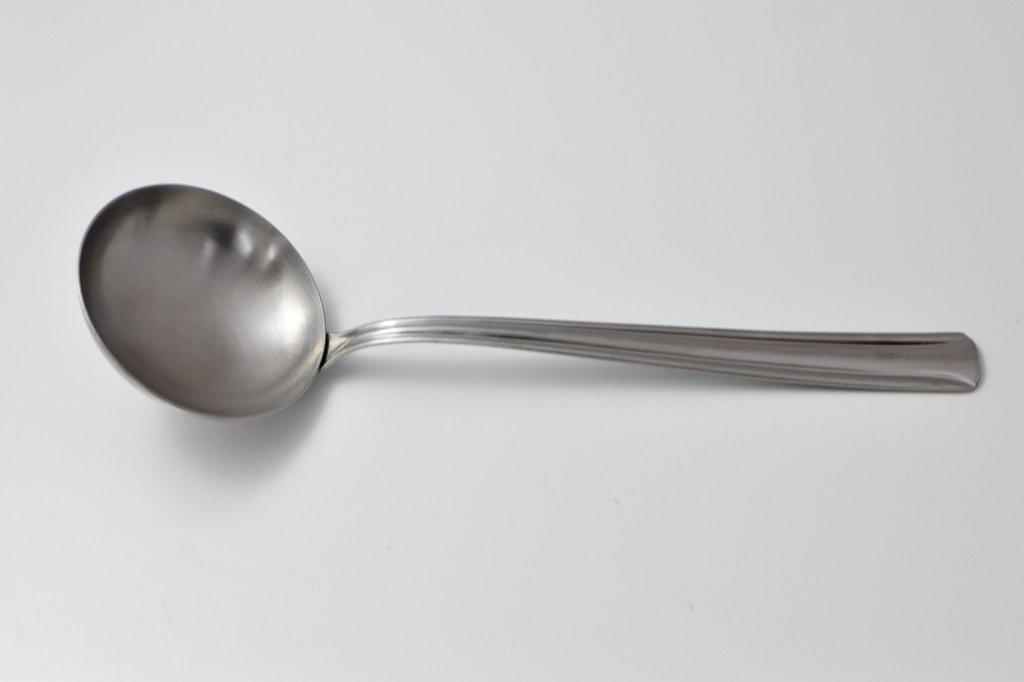What type of utensil is visible in the image? There is a metal spoon in the image. What color is the metal spoon? The metal spoon is grey in color. On what surface is the metal spoon placed? The metal spoon is on a white colored surface. What type of insect can be seen crawling on the metal spoon in the image? There are no insects present in the image; it only features a metal spoon on a white surface. 